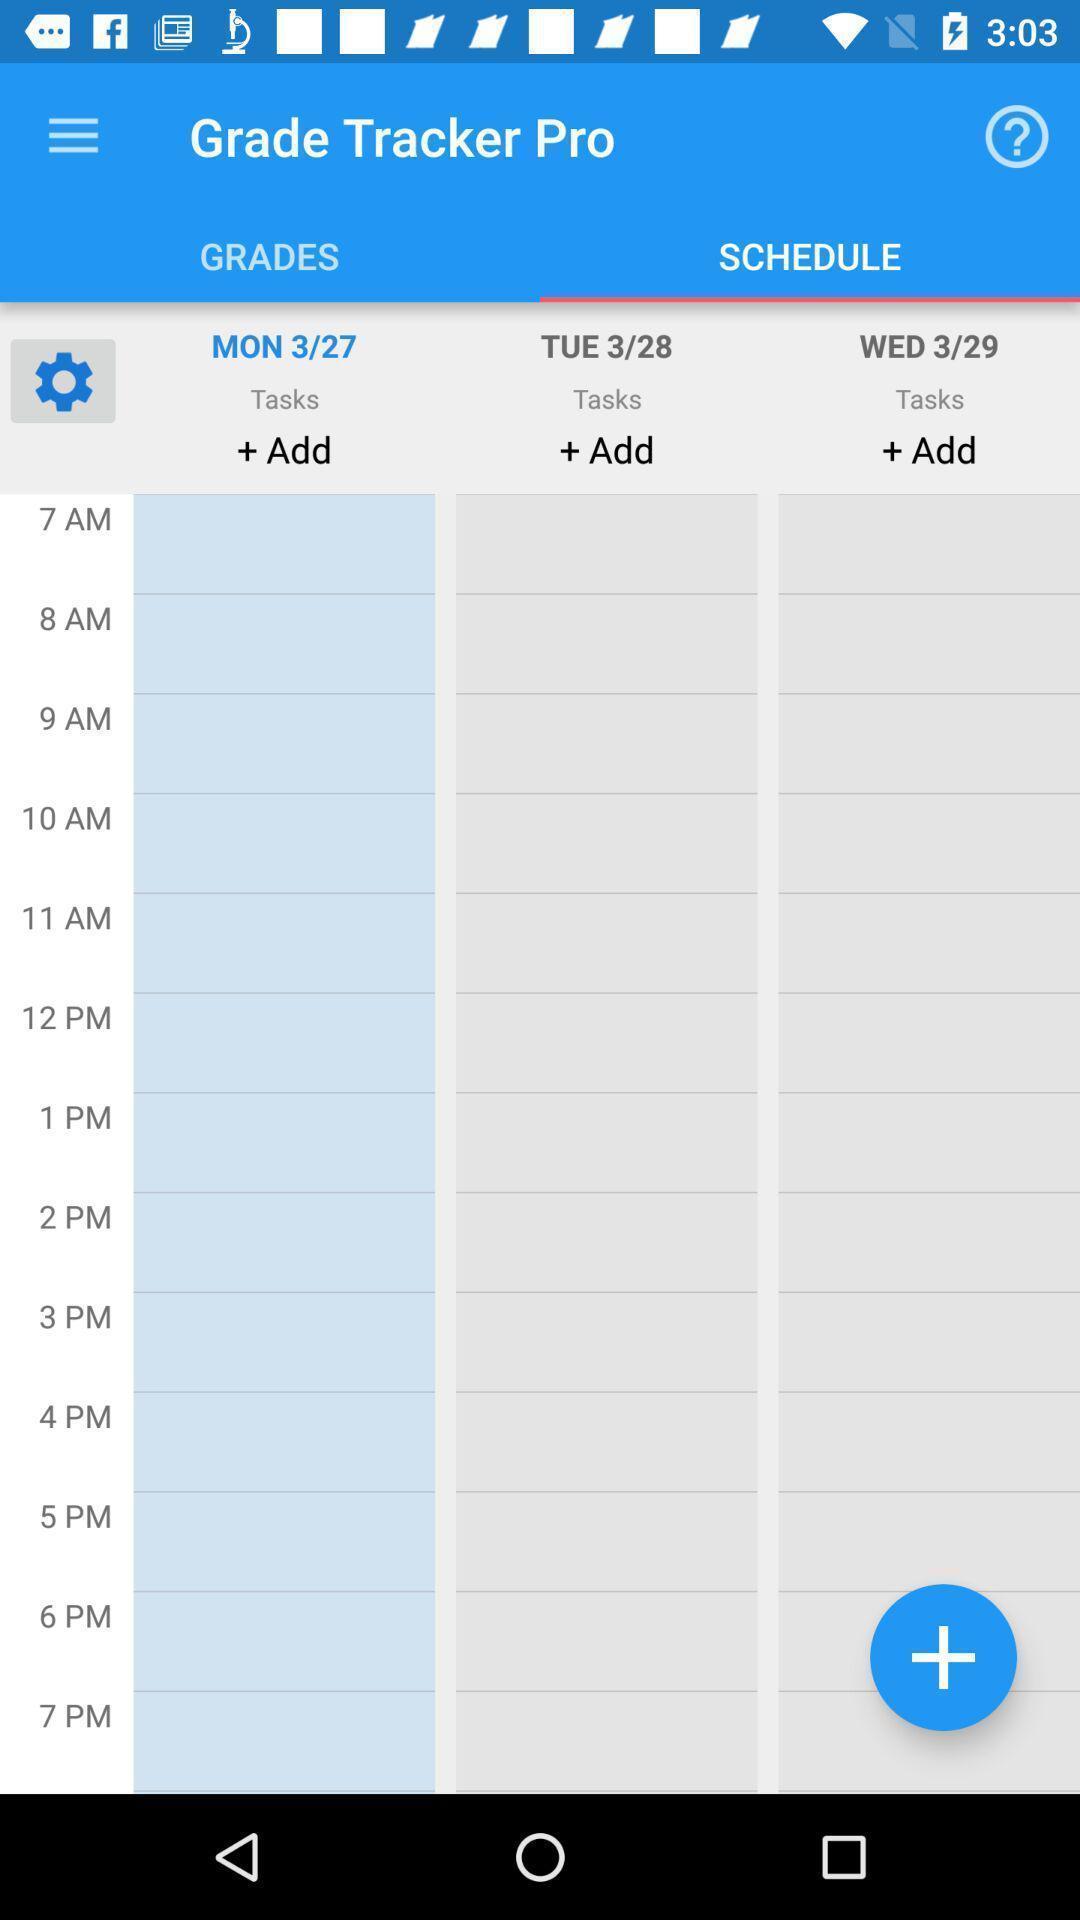Provide a detailed account of this screenshot. Screen displaying the schedule page. 